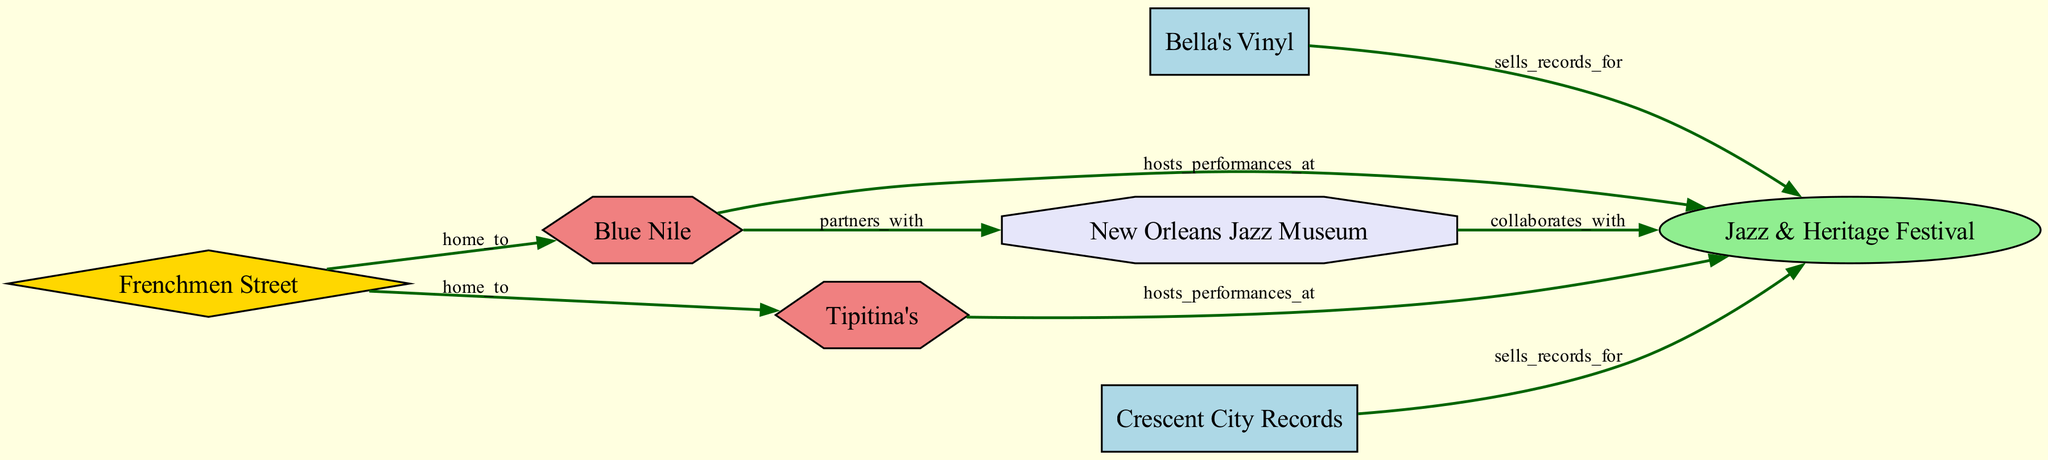What type of shop is Bella's Vinyl? Bella's Vinyl is classified as a vinyl shop according to the node type in the diagram.
Answer: vinyl shop How many jazz venues are shown in the diagram? The diagram features two jazz venues: Blue Nile and Tipitina's, which can be counted from the nodes listed.
Answer: 2 Which event do both Bella's Vinyl and Crescent City Records sell records for? The relationship labeled "sells_records_for" connects both shops to the Jazz & Heritage Festival, indicating it is the event they sell records for.
Answer: Jazz & Heritage Festival What is the relationship between Blue Nile and New Orleans Jazz Museum? The edge labeled "partners_with" shows that Blue Nile has a partnership with New Orleans Jazz Museum, indicating the type of relationship between these two nodes.
Answer: partners_with Which music street is home to both Blue Nile and Tipitina's? The diagram indicates that Frenchmen Street is connected to both Blue Nile and Tipitina's, thus it is the music street that serves as their location.
Answer: Frenchmen Street What type of event is the Jazz & Heritage Festival? The node type for the Jazz & Heritage Festival is categorized as an event in the diagram, which defines its classification.
Answer: event Which venues host performances at the Jazz & Heritage Festival? The diagram shows that both Blue Nile and Tipitina's are linked to the Jazz & Heritage Festival with the relationship "hosts_performances_at," indicating they host performances at this event.
Answer: Blue Nile and Tipitina's How many community events are listed in the diagram? There is one community event, the New Orleans Jazz Museum, which can be identified from the nodes provided.
Answer: 1 Which shop collaborates with the Jazz & Heritage Festival? The diagram illustrates a collaboration between the New Orleans Jazz Museum and the Jazz & Heritage Festival, indicating whom they work together with.
Answer: New Orleans Jazz Museum 